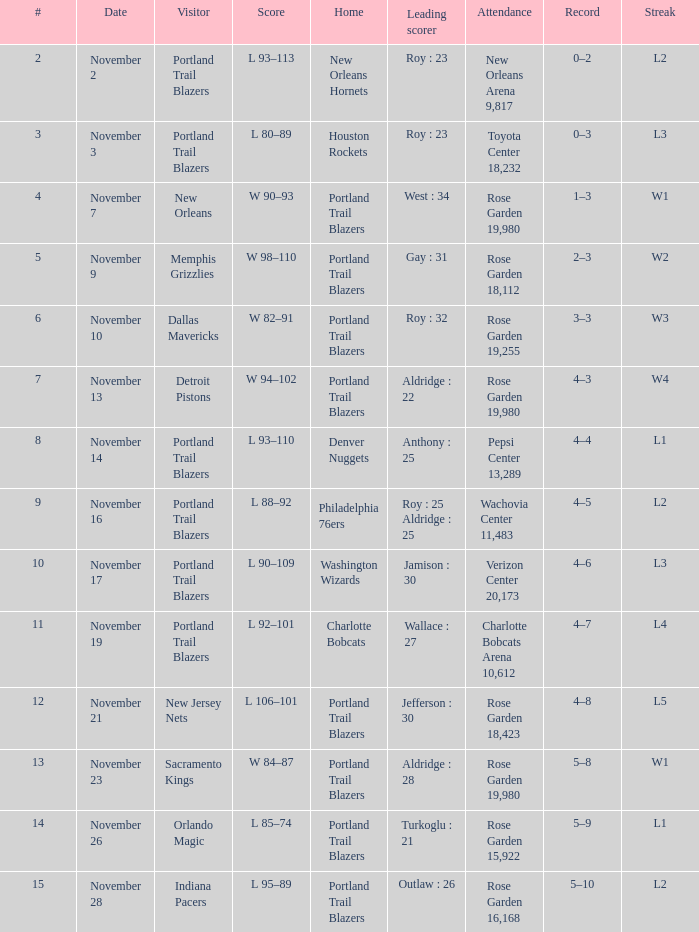Who is the principal point-maker for the charlotte bobcats during home matches? Wallace : 27. 